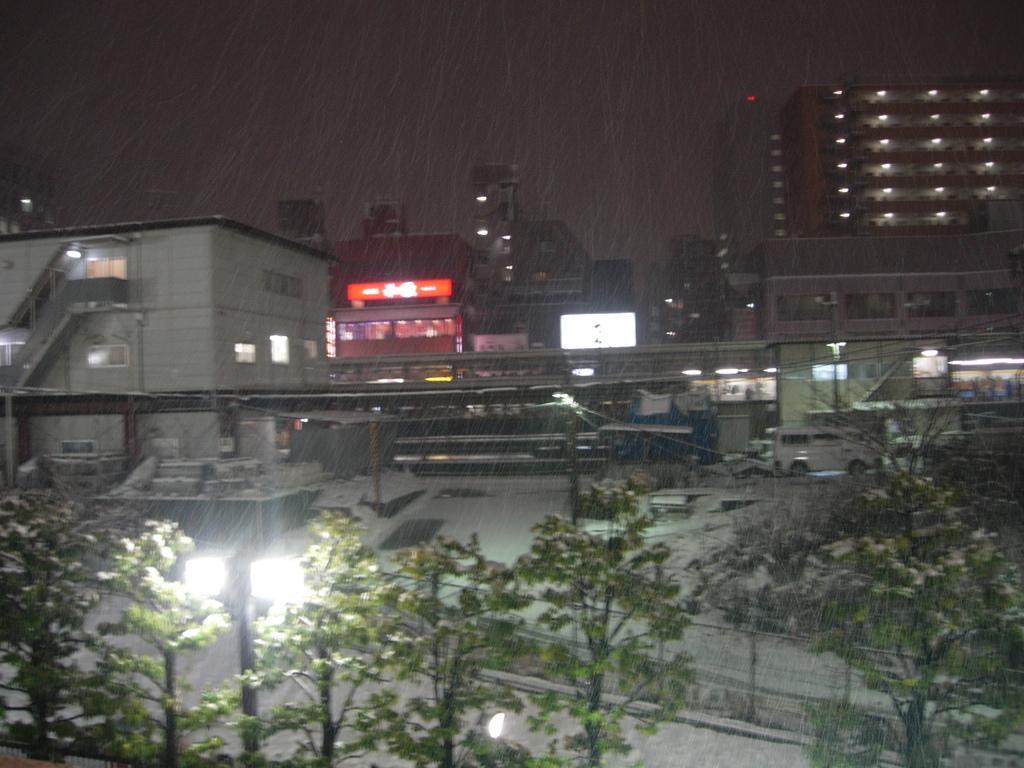Describe this image in one or two sentences. In this image there are buildings. In front of the buildings there are sheds. There are vehicles moving on the road. At the bottom there are trees and street light poles. There is snow on the ground. At the top there is the sky. It is snowing in the image. 